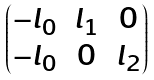<formula> <loc_0><loc_0><loc_500><loc_500>\begin{pmatrix} - l _ { 0 } & l _ { 1 } & 0 \\ - l _ { 0 } & 0 & l _ { 2 } \end{pmatrix}</formula> 